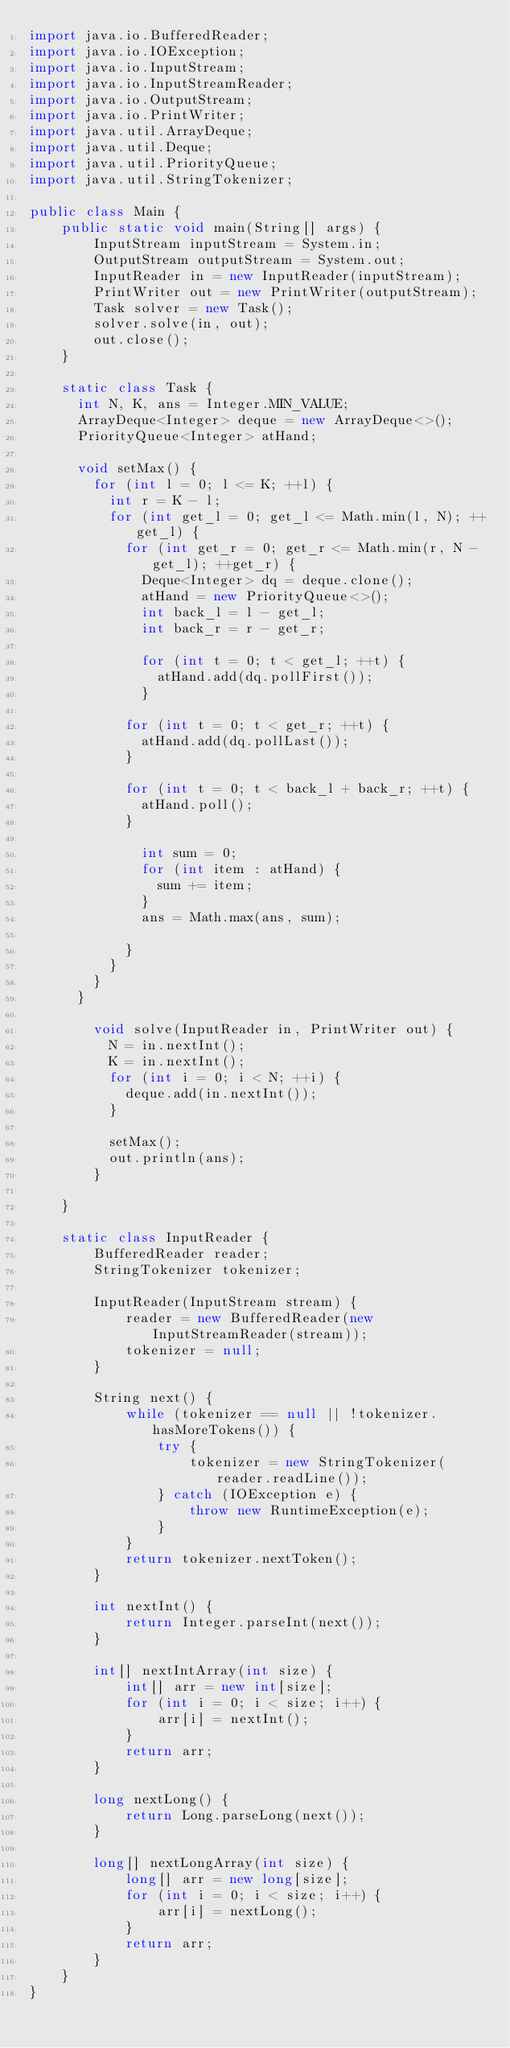Convert code to text. <code><loc_0><loc_0><loc_500><loc_500><_Java_>import java.io.BufferedReader;
import java.io.IOException;
import java.io.InputStream;
import java.io.InputStreamReader;
import java.io.OutputStream;
import java.io.PrintWriter;
import java.util.ArrayDeque;
import java.util.Deque;
import java.util.PriorityQueue;
import java.util.StringTokenizer;

public class Main {
    public static void main(String[] args) {
        InputStream inputStream = System.in;
        OutputStream outputStream = System.out;
        InputReader in = new InputReader(inputStream);
        PrintWriter out = new PrintWriter(outputStream);
        Task solver = new Task();
        solver.solve(in, out);
        out.close();
    }

    static class Task {
    	int N, K, ans = Integer.MIN_VALUE;
    	ArrayDeque<Integer> deque = new ArrayDeque<>();
    	PriorityQueue<Integer> atHand;
    	
    	void setMax() {
    		for (int l = 0; l <= K; ++l) {
    			int r = K - l;
    			for (int get_l = 0; get_l <= Math.min(l, N); ++get_l) {
    				for (int get_r = 0; get_r <= Math.min(r, N - get_l); ++get_r) {
    					Deque<Integer> dq = deque.clone();
    					atHand = new PriorityQueue<>();
    					int back_l = l - get_l;
    					int back_r = r - get_r;
    					
	    				for (int t = 0; t < get_l; ++t) {
	    					atHand.add(dq.pollFirst());
	    				}
	    				
						for (int t = 0; t < get_r; ++t) {
							atHand.add(dq.pollLast());
						}
						
						for (int t = 0; t < back_l + back_r; ++t) {
							atHand.poll();
						}
	    				
	    				int sum = 0;
	    				for (int item : atHand) {
	    					sum += item;
	    				}
	    				ans = Math.max(ans, sum);
    					
    				}
    			}
    		}
    	}
    	
        void solve(InputReader in, PrintWriter out) {
        	N = in.nextInt();
        	K = in.nextInt();
        	for (int i = 0; i < N; ++i) {
        		deque.add(in.nextInt());
        	}
        	
        	setMax();
        	out.println(ans);
        }
        
    }

    static class InputReader {
        BufferedReader reader;
        StringTokenizer tokenizer;

        InputReader(InputStream stream) {
            reader = new BufferedReader(new InputStreamReader(stream));
            tokenizer = null;
        }

        String next() {
            while (tokenizer == null || !tokenizer.hasMoreTokens()) {
                try {
                    tokenizer = new StringTokenizer(reader.readLine());
                } catch (IOException e) {
                    throw new RuntimeException(e);
                }
            }
            return tokenizer.nextToken();
        }

        int nextInt() {
            return Integer.parseInt(next());
        }

        int[] nextIntArray(int size) {
            int[] arr = new int[size];
            for (int i = 0; i < size; i++) {
                arr[i] = nextInt();
            }
            return arr;
        }

        long nextLong() {
            return Long.parseLong(next());
        }

        long[] nextLongArray(int size) {
            long[] arr = new long[size];
            for (int i = 0; i < size; i++) {
                arr[i] = nextLong();
            }
            return arr;
        }
    }
}
</code> 